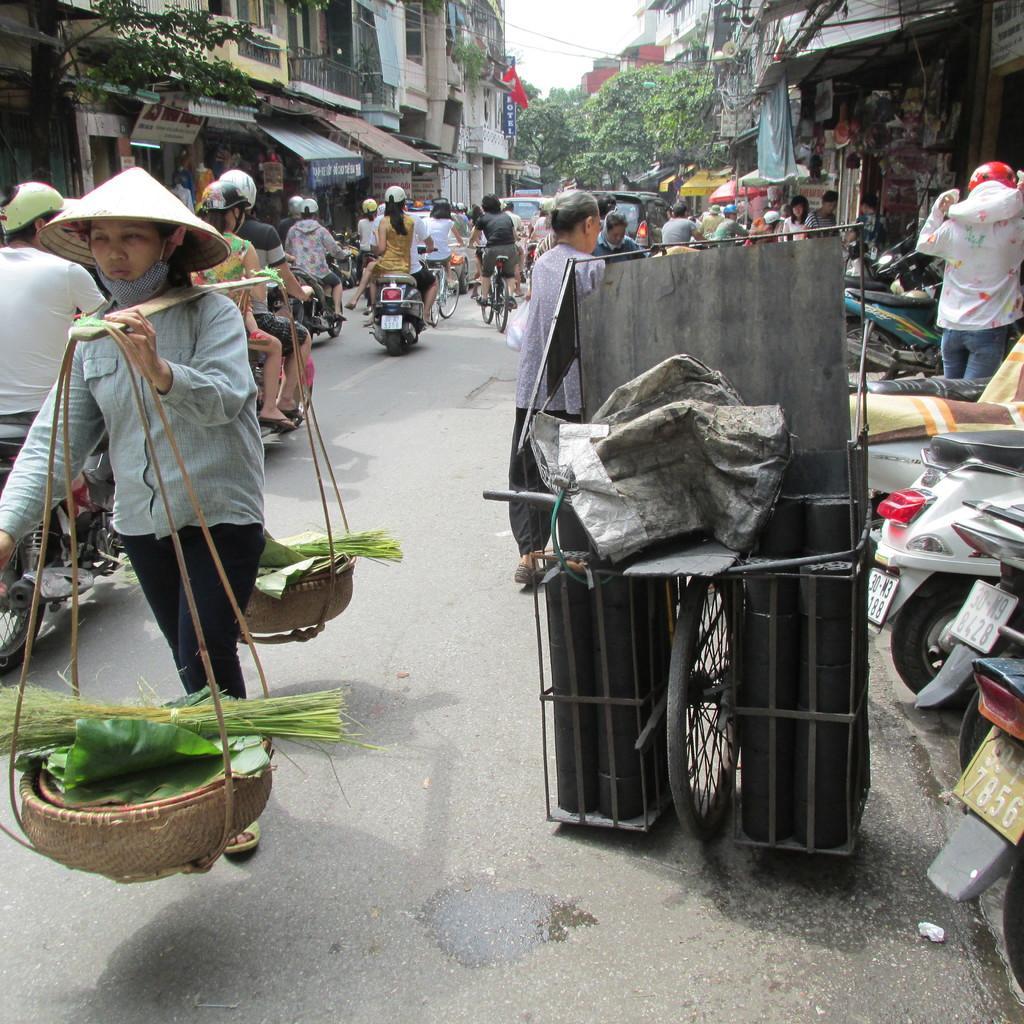Describe this image in one or two sentences. In this image I can see the road, a bicycle, a person standing, few persons riding motorbikes and few persons riding bicycles on the road. I can see few buildings on both sides of the road, few trees, few boards, to the right side of the image I can see few motorbikes and in the background I can see the sky. 